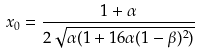Convert formula to latex. <formula><loc_0><loc_0><loc_500><loc_500>x _ { 0 } & = \frac { 1 + \alpha } { 2 \sqrt { \alpha ( 1 + 1 6 \alpha ( 1 - \beta ) ^ { 2 } ) } }</formula> 